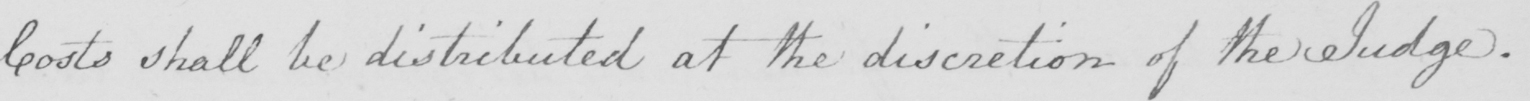Can you tell me what this handwritten text says? Costs shall be distributed at the discretion of the Judge . 